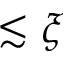<formula> <loc_0><loc_0><loc_500><loc_500>\lesssim \xi</formula> 